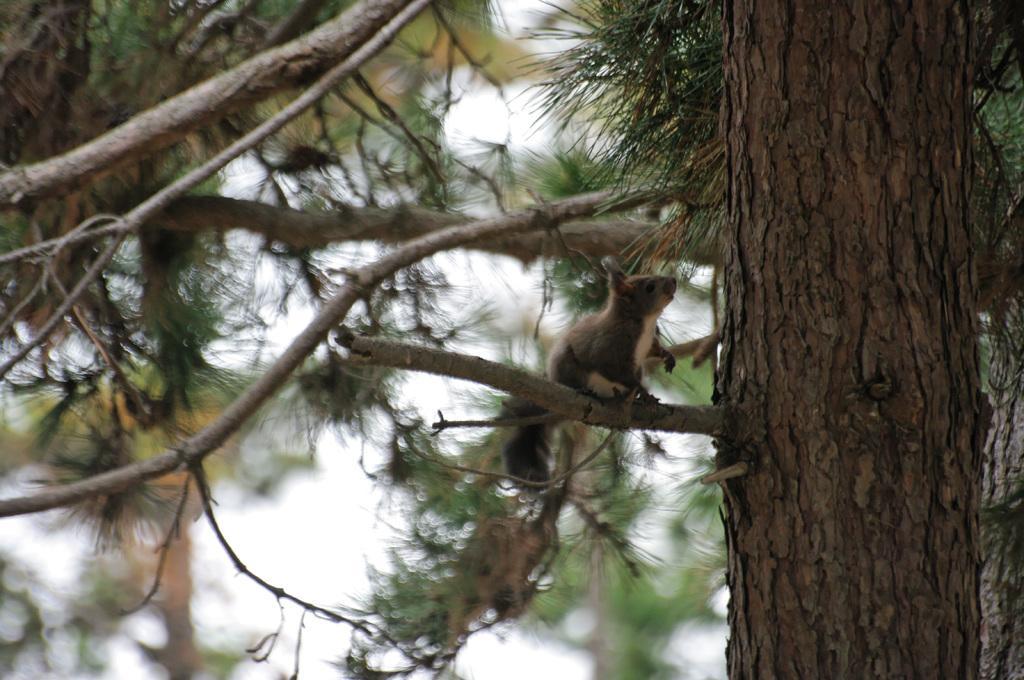Could you give a brief overview of what you see in this image? In this picture there is a brown color squirrel sitting on the tree branch. Behind we can see some green leaves and on the right corner there is a tree trunk. 